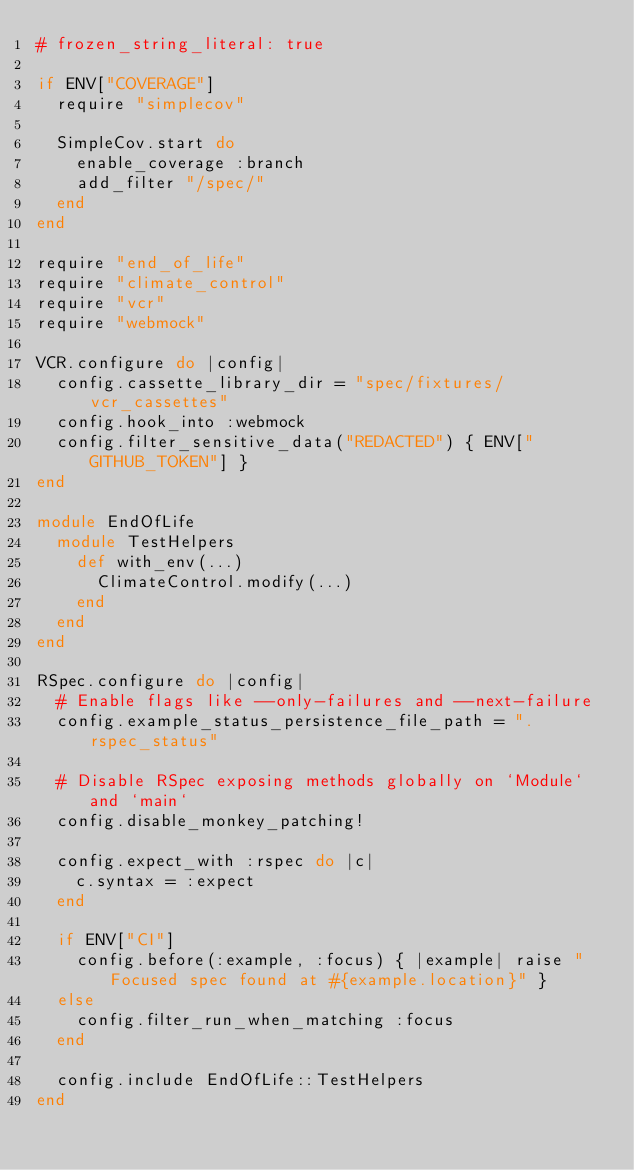<code> <loc_0><loc_0><loc_500><loc_500><_Ruby_># frozen_string_literal: true

if ENV["COVERAGE"]
  require "simplecov"

  SimpleCov.start do
    enable_coverage :branch
    add_filter "/spec/"
  end
end

require "end_of_life"
require "climate_control"
require "vcr"
require "webmock"

VCR.configure do |config|
  config.cassette_library_dir = "spec/fixtures/vcr_cassettes"
  config.hook_into :webmock
  config.filter_sensitive_data("REDACTED") { ENV["GITHUB_TOKEN"] }
end

module EndOfLife
  module TestHelpers
    def with_env(...)
      ClimateControl.modify(...)
    end
  end
end

RSpec.configure do |config|
  # Enable flags like --only-failures and --next-failure
  config.example_status_persistence_file_path = ".rspec_status"

  # Disable RSpec exposing methods globally on `Module` and `main`
  config.disable_monkey_patching!

  config.expect_with :rspec do |c|
    c.syntax = :expect
  end

  if ENV["CI"]
    config.before(:example, :focus) { |example| raise "Focused spec found at #{example.location}" }
  else
    config.filter_run_when_matching :focus
  end

  config.include EndOfLife::TestHelpers
end
</code> 